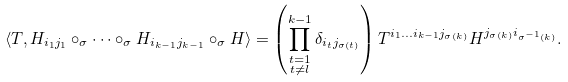<formula> <loc_0><loc_0><loc_500><loc_500>\langle T , H _ { i _ { 1 } j _ { 1 } } & \circ _ { \sigma } \cdots \circ _ { \sigma } H _ { i _ { k - 1 } j _ { k - 1 } } \circ _ { \sigma } H \rangle = \left ( \prod _ { \substack { t = 1 \\ t \not = l } } ^ { k - 1 } \delta _ { i _ { t } j _ { \sigma ( t ) } } \right ) T ^ { i _ { 1 } \dots i _ { k - 1 } j _ { \sigma ( k ) } } H ^ { j _ { \sigma ( k ) } i _ { \sigma ^ { - 1 } ( k ) } } .</formula> 